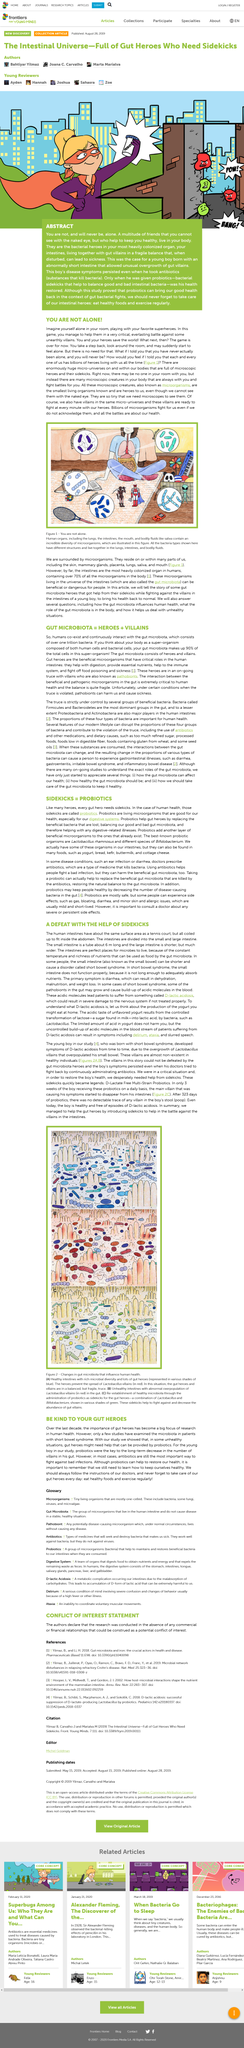List a handful of essential elements in this visual. There are several types of bacteria that reside within the human body, including flagellated bacteria, cocci and streptococci, diplobacilli, streptobacilli, and bacilli. Figure 2 displays alterations in gut microbiota that impact human health. Probiotics help gut heroes by replacing beneficial bacteria lost, balancing the good and bad microbiota, and aiding in the treatment of digestive-related illnesses. Commonly known probiotic organisms are Lactobacillus rhamnosus and different species of Bifidobacterium. Beneficial microorganisms are essential for maintaining a healthy gut. They aid in digestion, provide essential nutrients, strengthen the immune system, and combat foodborne illness and sickness. 